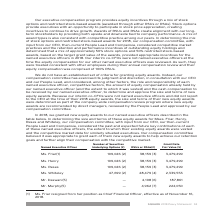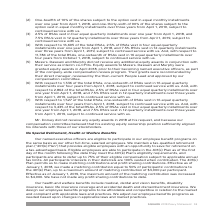According to Square's financial document, Why didn’t Mr. Dorsey receive any equity awards in 2018? Because our compensation committee believed that his existing equity ownership position sufficiently aligned his interests with those of our stockholders.. The document states: "eive any equity awards in 2018 at his request, and because our compensation committee believed that his existing equity ownership position sufficientl..." Also, When did Ms. Friar resign from her position? According to the financial document, November 16, 2018. The relevant text states: "ition as Chief Financial Officer, effective as of November 16, 2018...." Also, What factors are considered in determining the size and terms of the equity awards? The past and expected future key contributions of each of these named executive officers, the extent to which their existing equity awards were vested and the competitive market data for similarly situated executives. The document states: "hen-current People Lead and Compensia, considered the past and expected future key contributions of each of these named executive officers, the extent..." Also, can you calculate: What is the average number of securities underlying options of those executive officers who receive them? To answer this question, I need to perform calculations using the financial data. The calculation is: (109,026 + 109,026 + 109,026 + 47,699) / 4 , which equals 93694.25. This is based on the information: "Ms. Friar(1) 109,026 (2) 38,159 (3) 3,479,299 Ms. Whiteley 47,699 (2) 28,479 (4) 2,339,553..." The key data points involved are: 109,026, 47,699. Additionally, Which Executive Officer(s) has(have) the least number of RSUs or RSAs? According to the financial document, Mr. Daswani. The relevant text states: "Mr. Daswani(5) — 4,198 (6) 187,861..." Additionally, Which Executive Officer(s) has(have) the largest amount of Grant Date Fair Value? The document contains multiple relevant values: Ms. Friar, Ms. Henry, Ms. Reses. From the document: "Ms. Reses 109,026 (2) 38,159 (3) 3,479,299 Ms. Henry 109,026 (2) 38,159 (3) 3,479,299 Ms. Friar(1) 109,026 (2) 38,159 (3) 3,479,299..." 